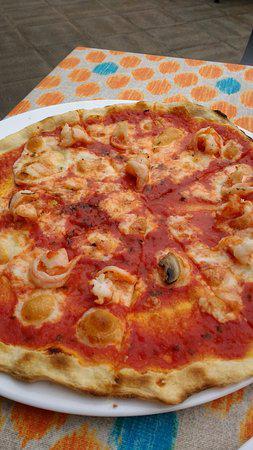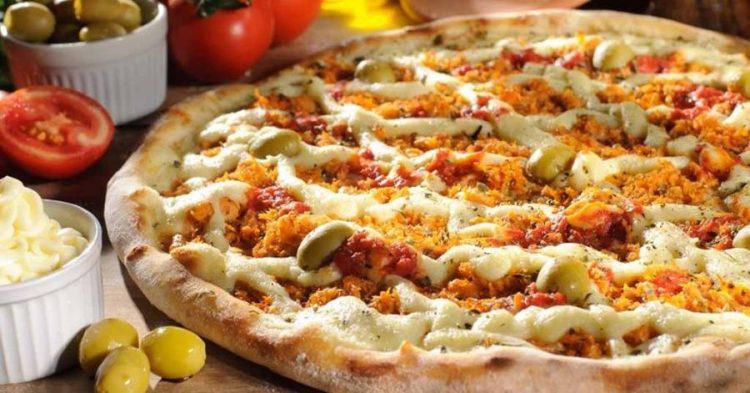The first image is the image on the left, the second image is the image on the right. Evaluate the accuracy of this statement regarding the images: "The left and right image contains the same number of pizzas.". Is it true? Answer yes or no. Yes. The first image is the image on the left, the second image is the image on the right. Assess this claim about the two images: "One image contains two pizzas and the other image contains one pizza.". Correct or not? Answer yes or no. No. 